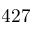Convert formula to latex. <formula><loc_0><loc_0><loc_500><loc_500>4 2 7</formula> 